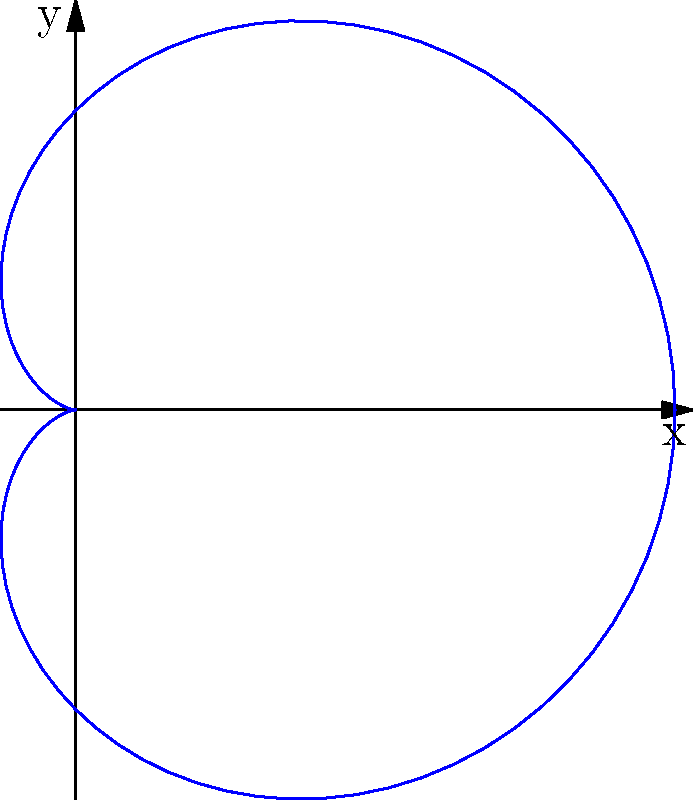In your theological studies, you encountered the concept of divine perfection, often symbolized by perfect geometric shapes. Consider the cardioid curve given by the polar equation $r = 2(1 + \cos\theta)$. This curve resembles a heart shape, which some theologians have used to represent God's love. Calculate the area enclosed by this cardioid curve. Let's approach this step-by-step:

1) The general formula for the area enclosed by a polar curve is:

   $$A = \frac{1}{2} \int_{0}^{2\pi} r^2 d\theta$$

2) In our case, $r = 2(1 + \cos\theta)$. We need to square this:

   $$r^2 = 4(1 + 2\cos\theta + \cos^2\theta)$$

3) Substituting this into our area formula:

   $$A = \frac{1}{2} \int_{0}^{2\pi} 4(1 + 2\cos\theta + \cos^2\theta) d\theta$$

4) Simplifying:

   $$A = 2 \int_{0}^{2\pi} (1 + 2\cos\theta + \cos^2\theta) d\theta$$

5) We can split this integral:

   $$A = 2 \int_{0}^{2\pi} d\theta + 4 \int_{0}^{2\pi} \cos\theta d\theta + 2 \int_{0}^{2\pi} \cos^2\theta d\theta$$

6) Let's evaluate each part:
   - $\int_{0}^{2\pi} d\theta = 2\pi$
   - $\int_{0}^{2\pi} \cos\theta d\theta = 0$
   - $\int_{0}^{2\pi} \cos^2\theta d\theta = \pi$

7) Substituting these back:

   $$A = 2(2\pi) + 4(0) + 2(\pi) = 4\pi + 2\pi = 6\pi$$

Therefore, the area enclosed by the cardioid is $6\pi$ square units.
Answer: $6\pi$ square units 